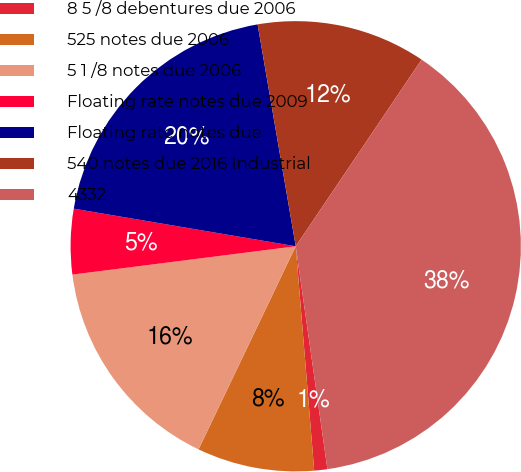<chart> <loc_0><loc_0><loc_500><loc_500><pie_chart><fcel>8 5 /8 debentures due 2006<fcel>525 notes due 2006<fcel>5 1 /8 notes due 2006<fcel>Floating rate notes due 2009<fcel>Floating rate notes due<fcel>540 notes due 2016 Industrial<fcel>4332<nl><fcel>0.94%<fcel>8.41%<fcel>15.89%<fcel>4.68%<fcel>19.62%<fcel>12.15%<fcel>38.31%<nl></chart> 